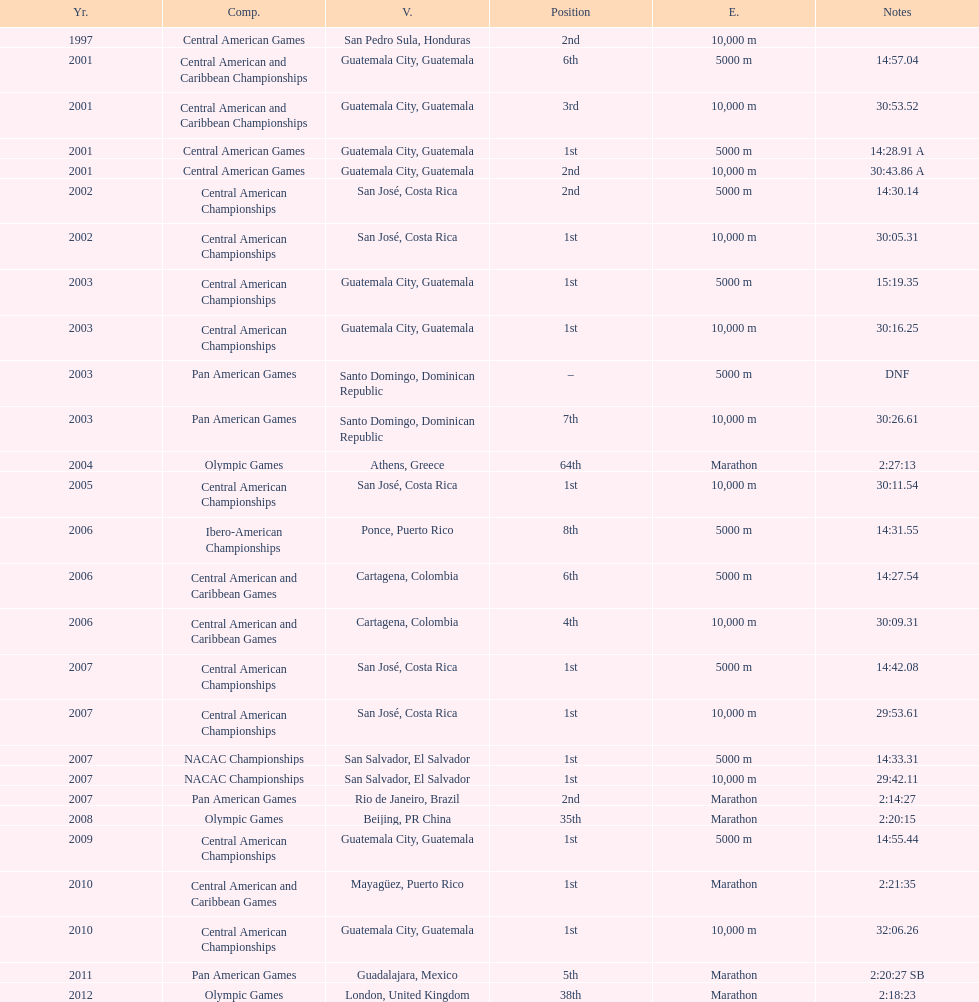Where was the only 64th position held? Athens, Greece. 